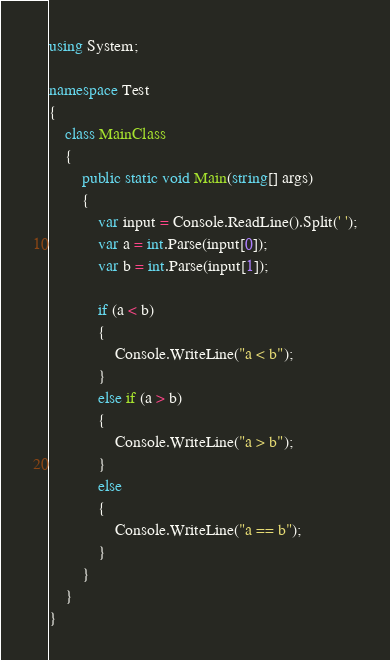Convert code to text. <code><loc_0><loc_0><loc_500><loc_500><_C#_>using System;

namespace Test
{
    class MainClass
    {
        public static void Main(string[] args)
        {
            var input = Console.ReadLine().Split(' ');
            var a = int.Parse(input[0]);
            var b = int.Parse(input[1]);

            if (a < b)
            {
                Console.WriteLine("a < b");
            }
            else if (a > b)
            {
                Console.WriteLine("a > b");
            }
            else
            {
                Console.WriteLine("a == b");
            }
        }
    }
}</code> 